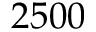<formula> <loc_0><loc_0><loc_500><loc_500>2 5 0 0</formula> 